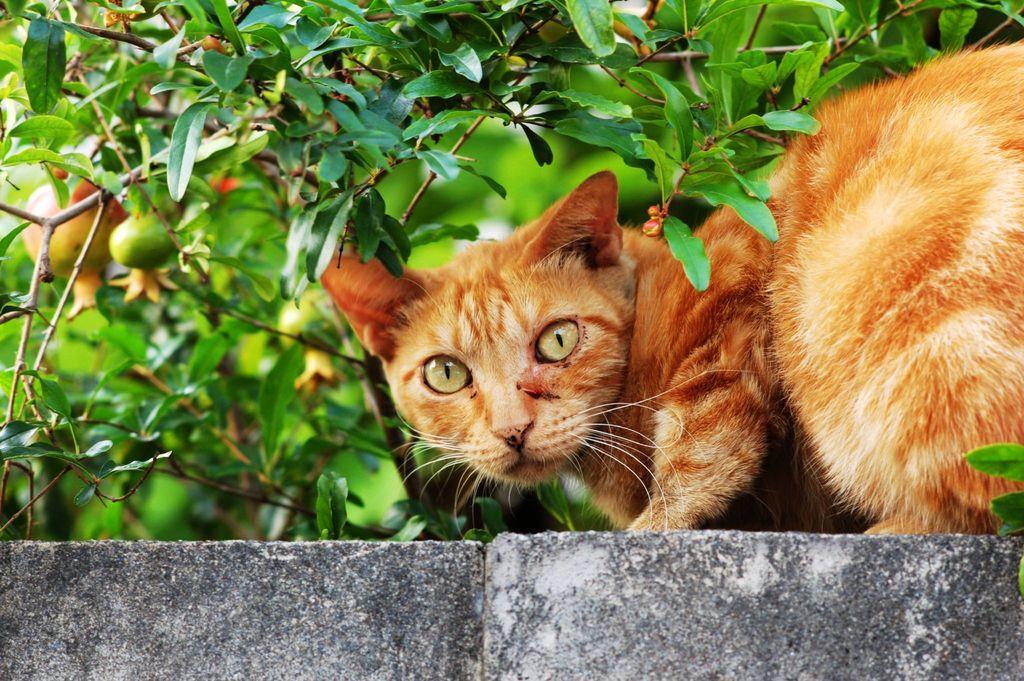Please provide a concise description of this image. In this picture I can observe a green and brown color cat on the wall. The wall is in grey color. I can observe pomegranate tree in the background. 